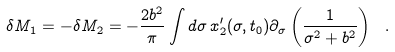Convert formula to latex. <formula><loc_0><loc_0><loc_500><loc_500>\delta M _ { 1 } = - \delta M _ { 2 } = - \frac { 2 b ^ { 2 } } { \pi } \int d \sigma \, x _ { 2 } ^ { \prime } ( \sigma , t _ { 0 } ) \partial _ { \sigma } \left ( \frac { 1 } { \sigma ^ { 2 } + b ^ { 2 } } \right ) \ .</formula> 